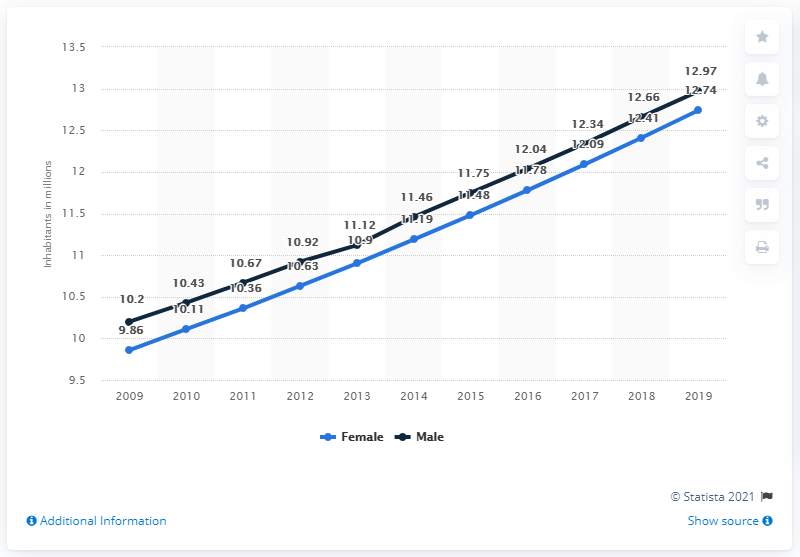Give some essential details in this illustration. In 2019, the male population of the Ivory Coast was 12.97 million. In 2019, the female population of the Ivory Coast was 12.74 million. 